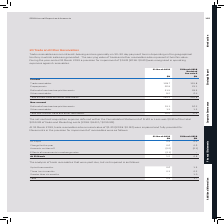According to Sophos Group's financial document, What was the amount of trade receivables that were impaired and fully provided for in 2019? nominal value of $1.2M. The document states: "At 31 March 2019, trade receivables at a nominal value of $1.2M (2018: $0.9M) were impaired and fully provided for. Movements in the provision for imp..." Also, What was the  Charge for the year for 2019? According to the financial document, 0.6 (in millions). The relevant text states: "Charge for the year 0.6 0.6..." Also, For which years were the movements in the provision for impairment of receivables provided? The document shows two values: 2019 and 2018. From the document: "31 March 2019 $M 31 March 2018 $M 31 March 2019 $M 31 March 2018 $M..." Additionally, In which year was the amount at 31 March larger? According to the financial document, 2019. The relevant text states: "31 March 2019 $M 31 March 2018 $M..." Also, can you calculate: What was the change in the value at 31 March in 2019 from 2018? Based on the calculation: 1.2-0.9, the result is 0.3 (in millions). This is based on the information: "At 31 March 1.2 0.9 At 31 March 1.2 0.9..." The key data points involved are: 0.9, 1.2. Also, can you calculate: What was the percentage change in the value at 31 March in 2019 from 2018? To answer this question, I need to perform calculations using the financial data. The calculation is: (1.2-0.9)/0.9, which equals 33.33 (percentage). This is based on the information: "At 31 March 1.2 0.9 At 31 March 1.2 0.9..." The key data points involved are: 0.9, 1.2. 